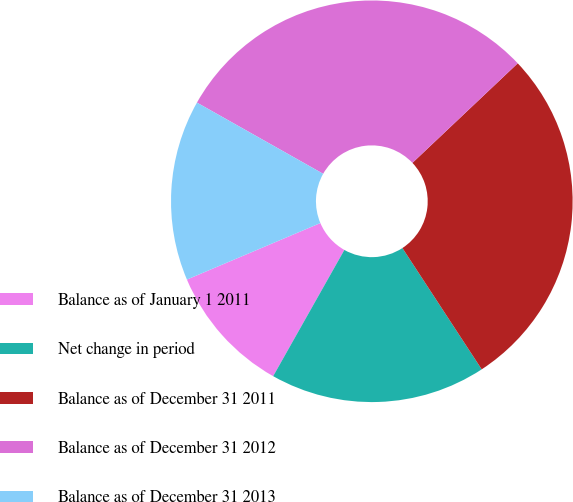Convert chart to OTSL. <chart><loc_0><loc_0><loc_500><loc_500><pie_chart><fcel>Balance as of January 1 2011<fcel>Net change in period<fcel>Balance as of December 31 2011<fcel>Balance as of December 31 2012<fcel>Balance as of December 31 2013<nl><fcel>10.45%<fcel>17.39%<fcel>27.84%<fcel>29.77%<fcel>14.55%<nl></chart> 